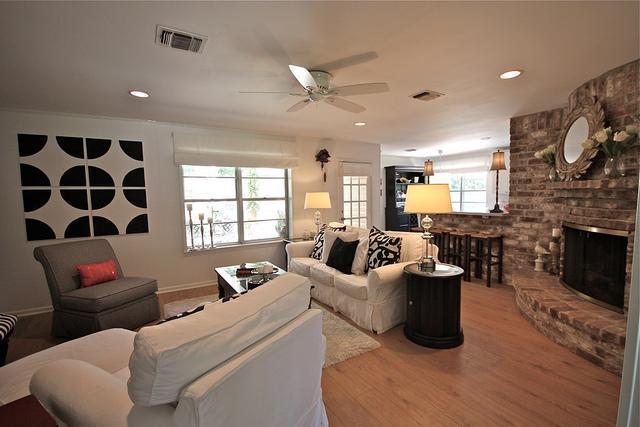How many pillows are on the couches?
Give a very brief answer. 5. How many couches can you see?
Give a very brief answer. 2. 